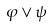<formula> <loc_0><loc_0><loc_500><loc_500>\varphi \vee \psi</formula> 